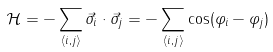Convert formula to latex. <formula><loc_0><loc_0><loc_500><loc_500>\mathcal { H } = - \sum _ { \left < i , j \right > } \vec { \sigma } _ { i } \cdot \vec { \sigma } _ { j } = - \sum _ { \left < i , j \right > } \cos ( \varphi _ { i } - \varphi _ { j } )</formula> 